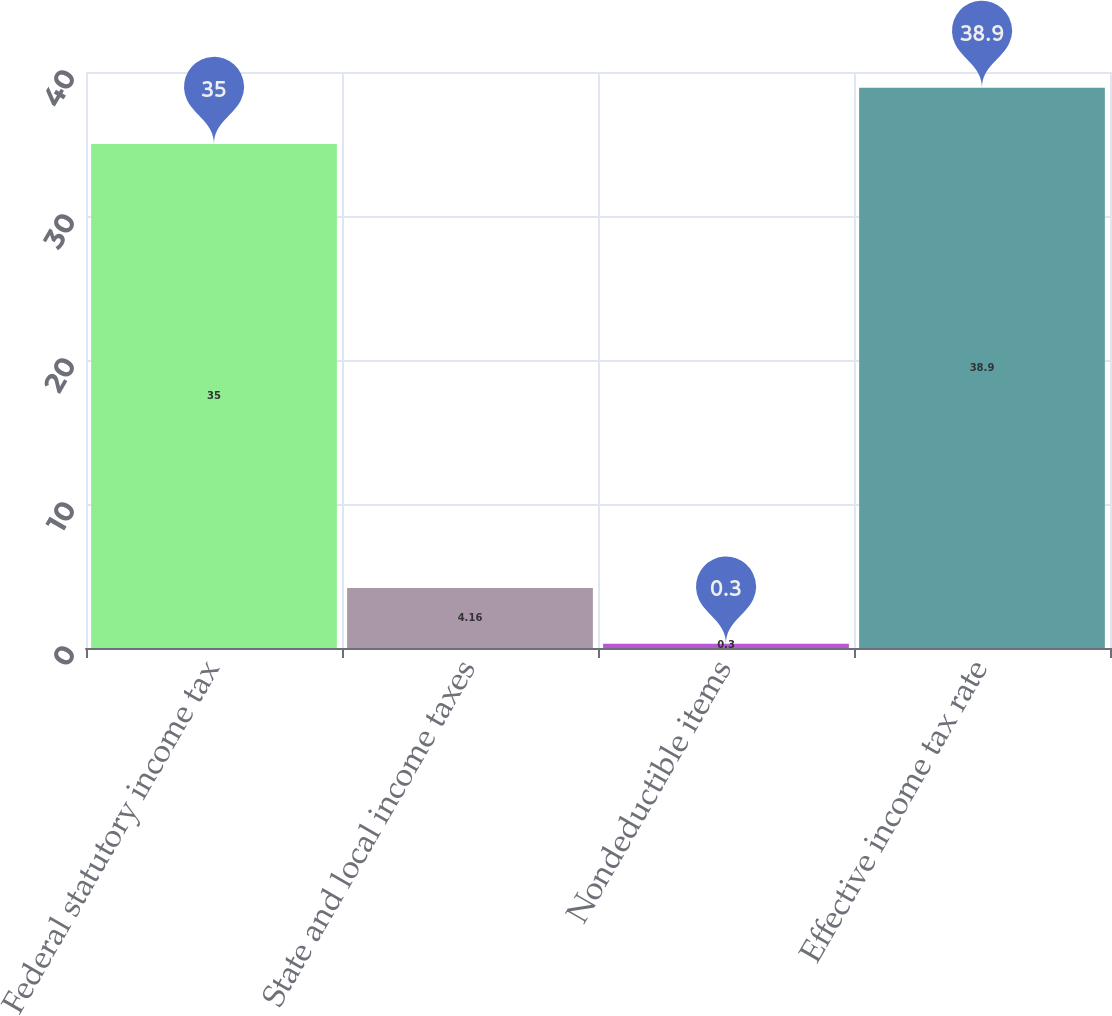Convert chart. <chart><loc_0><loc_0><loc_500><loc_500><bar_chart><fcel>Federal statutory income tax<fcel>State and local income taxes<fcel>Nondeductible items<fcel>Effective income tax rate<nl><fcel>35<fcel>4.16<fcel>0.3<fcel>38.9<nl></chart> 